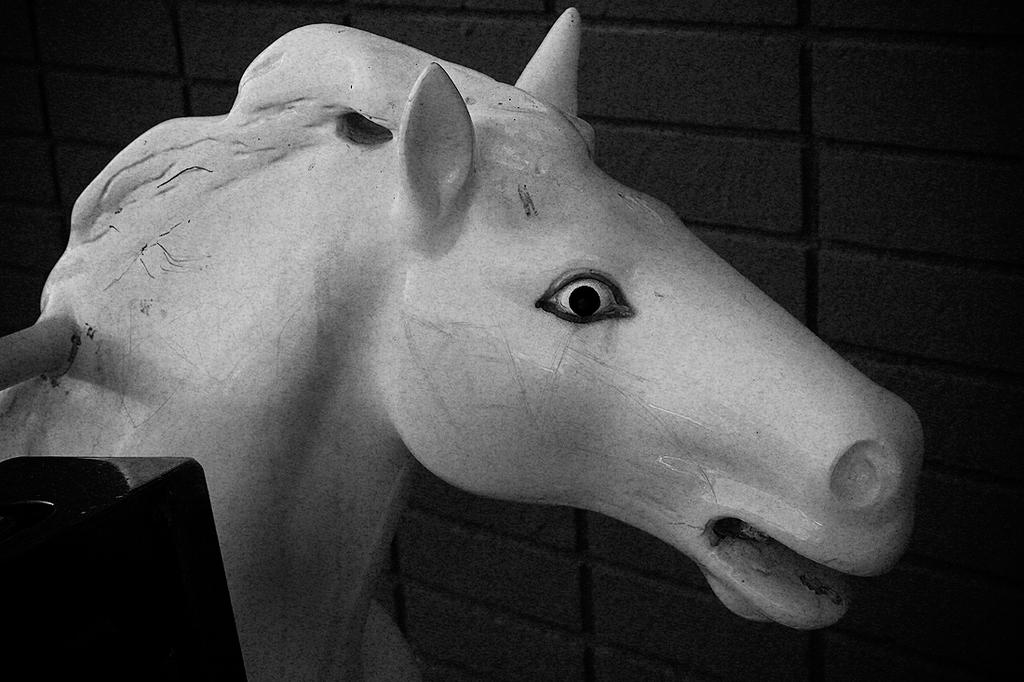What type of object is depicted as the main subject in the image? There is a statue of an animal in the image. What can be seen in the foreground of the image? There is an object in the foreground of the image. What is visible in the background of the image? There is a wall visible in the background of the image. How many planes are flying over the statue in the image? There are no planes visible in the image; it only features a statue of an animal and other objects. 